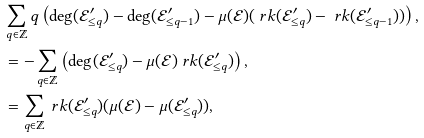<formula> <loc_0><loc_0><loc_500><loc_500>& \sum _ { q \in \mathbb { Z } } q \left ( \deg ( \mathcal { E } ^ { \prime } _ { \leq q } ) - \deg ( \mathcal { E } ^ { \prime } _ { \leq q - 1 } ) - \mu ( \mathcal { E } ) ( \ r k ( \mathcal { E } ^ { \prime } _ { \leq q } ) - \ r k ( \mathcal { E } ^ { \prime } _ { \leq q - 1 } ) ) \right ) , \\ & = - \sum _ { q \in \mathbb { Z } } \left ( \deg ( \mathcal { E } ^ { \prime } _ { \leq q } ) - \mu ( \mathcal { E } ) \ r k ( \mathcal { E } ^ { \prime } _ { \leq q } ) \right ) , \\ & = \sum _ { q \in \mathbb { Z } } \ r k ( \mathcal { E } ^ { \prime } _ { \leq q } ) ( \mu ( \mathcal { E } ) - \mu ( \mathcal { E } ^ { \prime } _ { \leq q } ) ) ,</formula> 